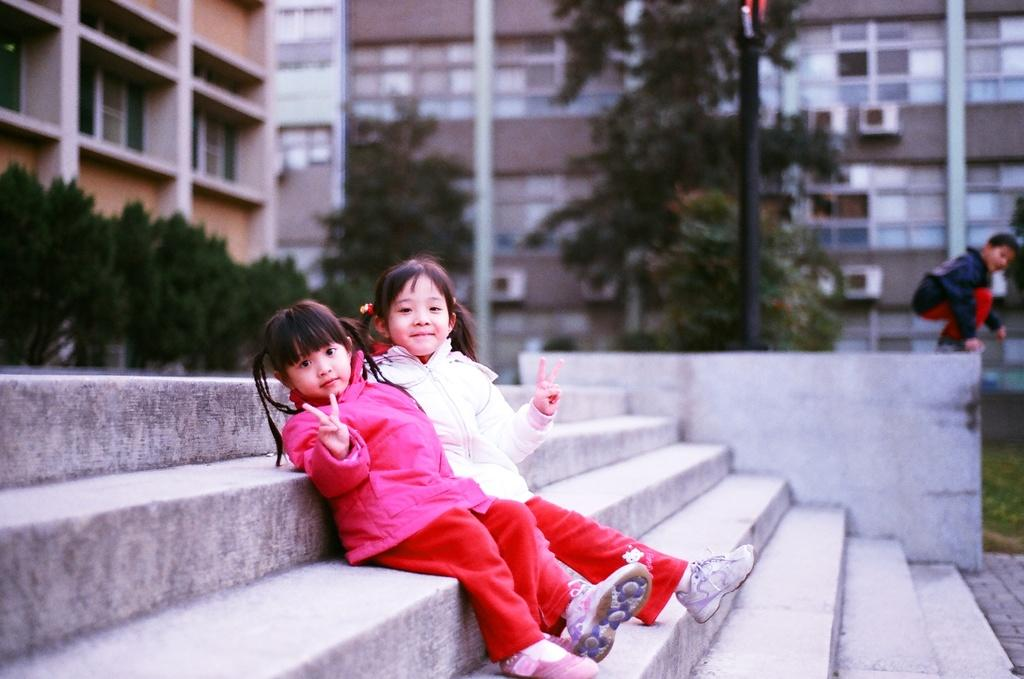How many people are in the image? There are three people in the image. What are the people wearing? The people are wearing different color dresses. Where are two of the people sitting? Two people are sitting on the stairs. What can be seen in the background of the image? There are poles, trees, and buildings in the background of the image. What type of noise can be heard coming from the jellyfish in the image? There are no jellyfish present in the image, so it's not possible to determine what, if any, noise might be heard. 